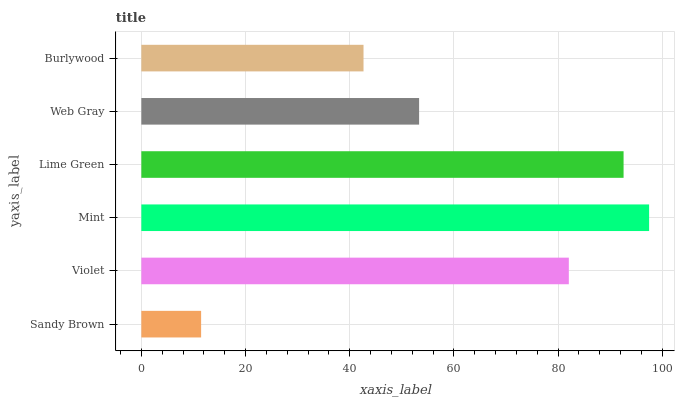Is Sandy Brown the minimum?
Answer yes or no. Yes. Is Mint the maximum?
Answer yes or no. Yes. Is Violet the minimum?
Answer yes or no. No. Is Violet the maximum?
Answer yes or no. No. Is Violet greater than Sandy Brown?
Answer yes or no. Yes. Is Sandy Brown less than Violet?
Answer yes or no. Yes. Is Sandy Brown greater than Violet?
Answer yes or no. No. Is Violet less than Sandy Brown?
Answer yes or no. No. Is Violet the high median?
Answer yes or no. Yes. Is Web Gray the low median?
Answer yes or no. Yes. Is Web Gray the high median?
Answer yes or no. No. Is Violet the low median?
Answer yes or no. No. 